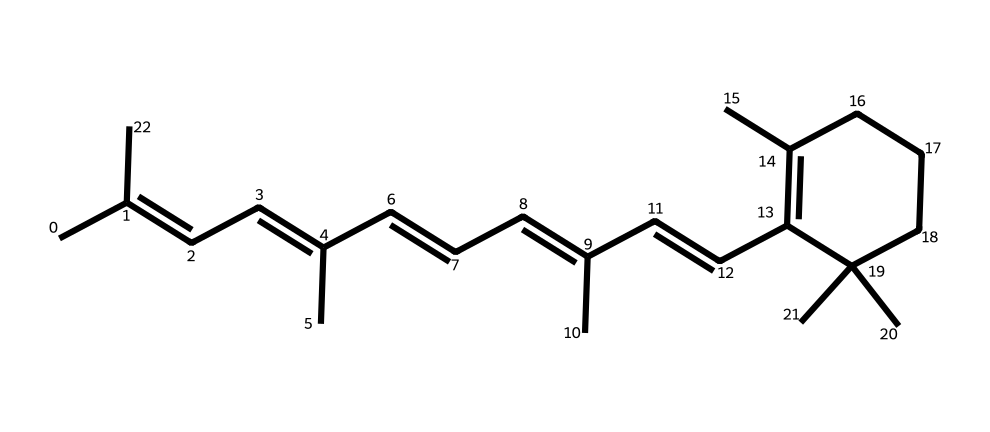How many double bonds are present in this compound? The structure shows the presence of five C=C double bonds in the main chain, as indicated by the alternating double bond connectivity in the SMILES representation. Each occurrence of "=" signifies a double bond.
Answer: five What is the function of retinal in the human body? Retinal is a crucial molecule in the visual cycle; it acts as a chromophore and is involved in converting light into visual signals in the retina. This function is tied to its geometric isomerism, as cis-trans isomerization occurs upon light absorption.
Answer: vision How does the cis form of retinal differ from the trans form? In the cis form, the substituents around the double bond are on the same side, leading to a bent configuration, whereas in the trans form, they are on opposite sides, resulting in a straighter configuration. This difference affects the molecule's interaction with proteins in the visual cycle.
Answer: side Which part of retinal undergoes isomerization during the visual process? The C11=C12 double bond of retinal undergoes isomerization from cis to trans upon light activation, which is crucial for the visual signaling process. This specific double bond is identified based on its position in the overall structure.
Answer: C11=C12 What is the significance of geometric isomerism in retinal? Geometric isomerism is essential because the different spatial arrangements significantly influence the molecule's ability to bind to opsin proteins and subsequently trigger the visual signal transduction pathway. This is vital for proper vision functionality.
Answer: binding 